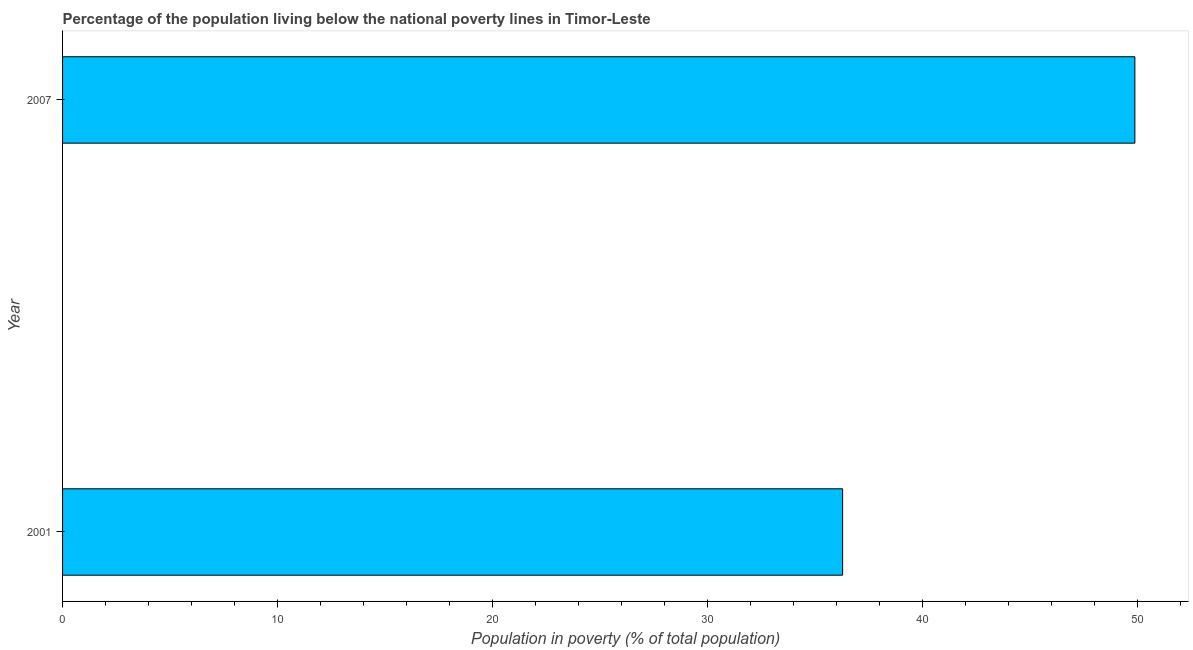Does the graph contain any zero values?
Make the answer very short. No. Does the graph contain grids?
Offer a very short reply. No. What is the title of the graph?
Offer a terse response. Percentage of the population living below the national poverty lines in Timor-Leste. What is the label or title of the X-axis?
Keep it short and to the point. Population in poverty (% of total population). What is the label or title of the Y-axis?
Your response must be concise. Year. What is the percentage of population living below poverty line in 2007?
Ensure brevity in your answer.  49.9. Across all years, what is the maximum percentage of population living below poverty line?
Give a very brief answer. 49.9. Across all years, what is the minimum percentage of population living below poverty line?
Your answer should be compact. 36.3. In which year was the percentage of population living below poverty line minimum?
Ensure brevity in your answer.  2001. What is the sum of the percentage of population living below poverty line?
Keep it short and to the point. 86.2. What is the average percentage of population living below poverty line per year?
Provide a short and direct response. 43.1. What is the median percentage of population living below poverty line?
Provide a succinct answer. 43.1. Do a majority of the years between 2001 and 2007 (inclusive) have percentage of population living below poverty line greater than 32 %?
Your answer should be very brief. Yes. What is the ratio of the percentage of population living below poverty line in 2001 to that in 2007?
Make the answer very short. 0.73. Is the percentage of population living below poverty line in 2001 less than that in 2007?
Offer a terse response. Yes. In how many years, is the percentage of population living below poverty line greater than the average percentage of population living below poverty line taken over all years?
Your answer should be compact. 1. How many bars are there?
Give a very brief answer. 2. What is the Population in poverty (% of total population) in 2001?
Ensure brevity in your answer.  36.3. What is the Population in poverty (% of total population) in 2007?
Keep it short and to the point. 49.9. What is the difference between the Population in poverty (% of total population) in 2001 and 2007?
Provide a succinct answer. -13.6. What is the ratio of the Population in poverty (% of total population) in 2001 to that in 2007?
Provide a succinct answer. 0.73. 